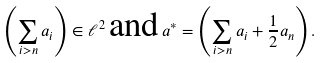<formula> <loc_0><loc_0><loc_500><loc_500>\left ( \sum _ { i > n } a _ { i } \right ) \in \ell ^ { 2 } \, \text {and} \, a ^ { * } = \left ( \sum _ { i > n } a _ { i } + \frac { 1 } { 2 } a _ { n } \right ) .</formula> 